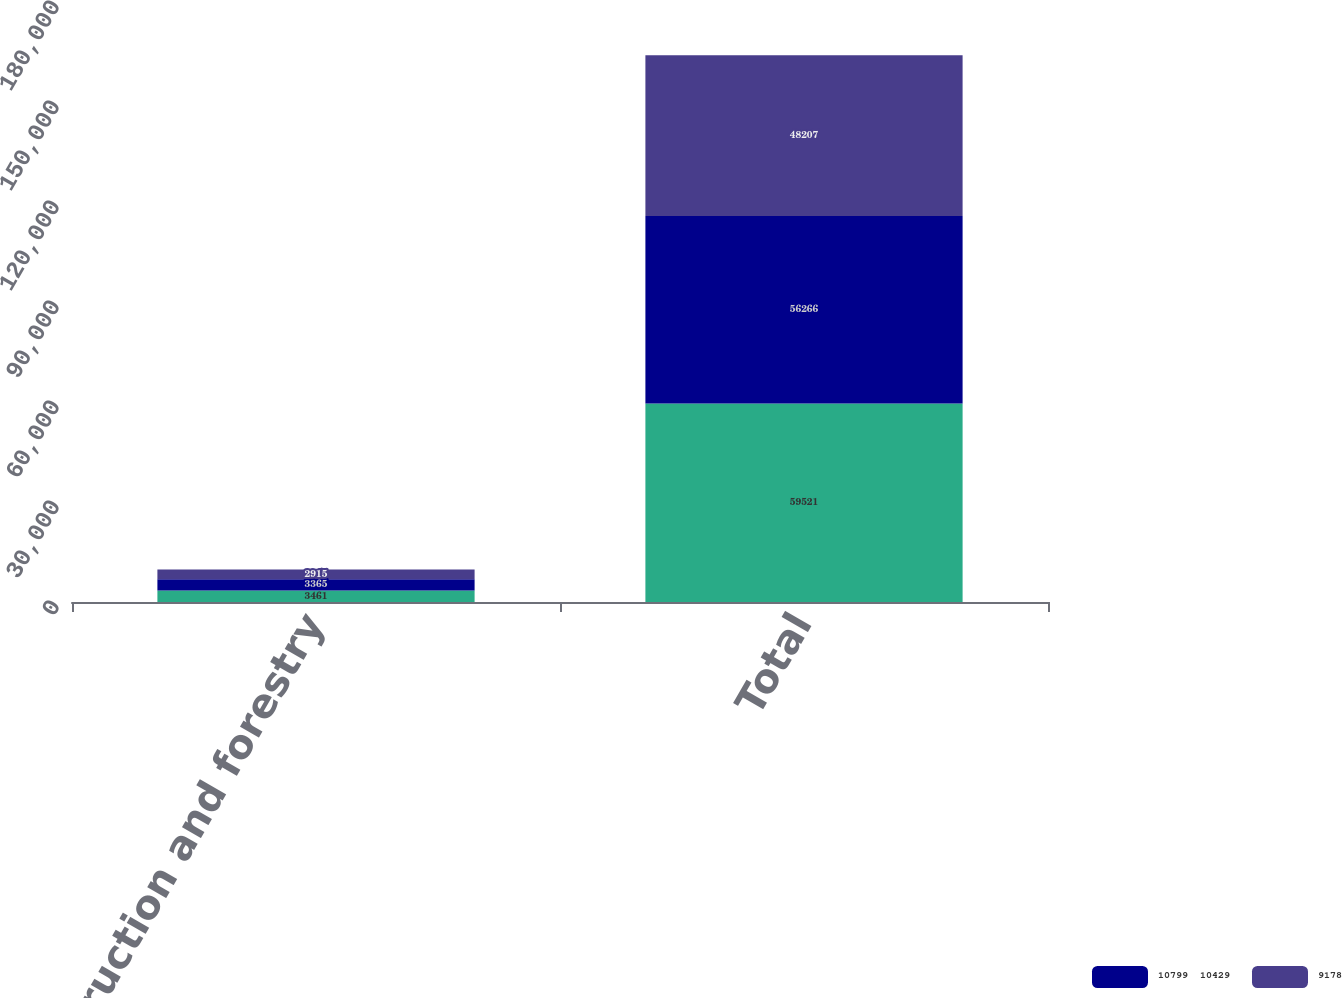Convert chart to OTSL. <chart><loc_0><loc_0><loc_500><loc_500><stacked_bar_chart><ecel><fcel>Construction and forestry<fcel>Total<nl><fcel>nan<fcel>3461<fcel>59521<nl><fcel>10799  10429<fcel>3365<fcel>56266<nl><fcel>9178<fcel>2915<fcel>48207<nl></chart> 